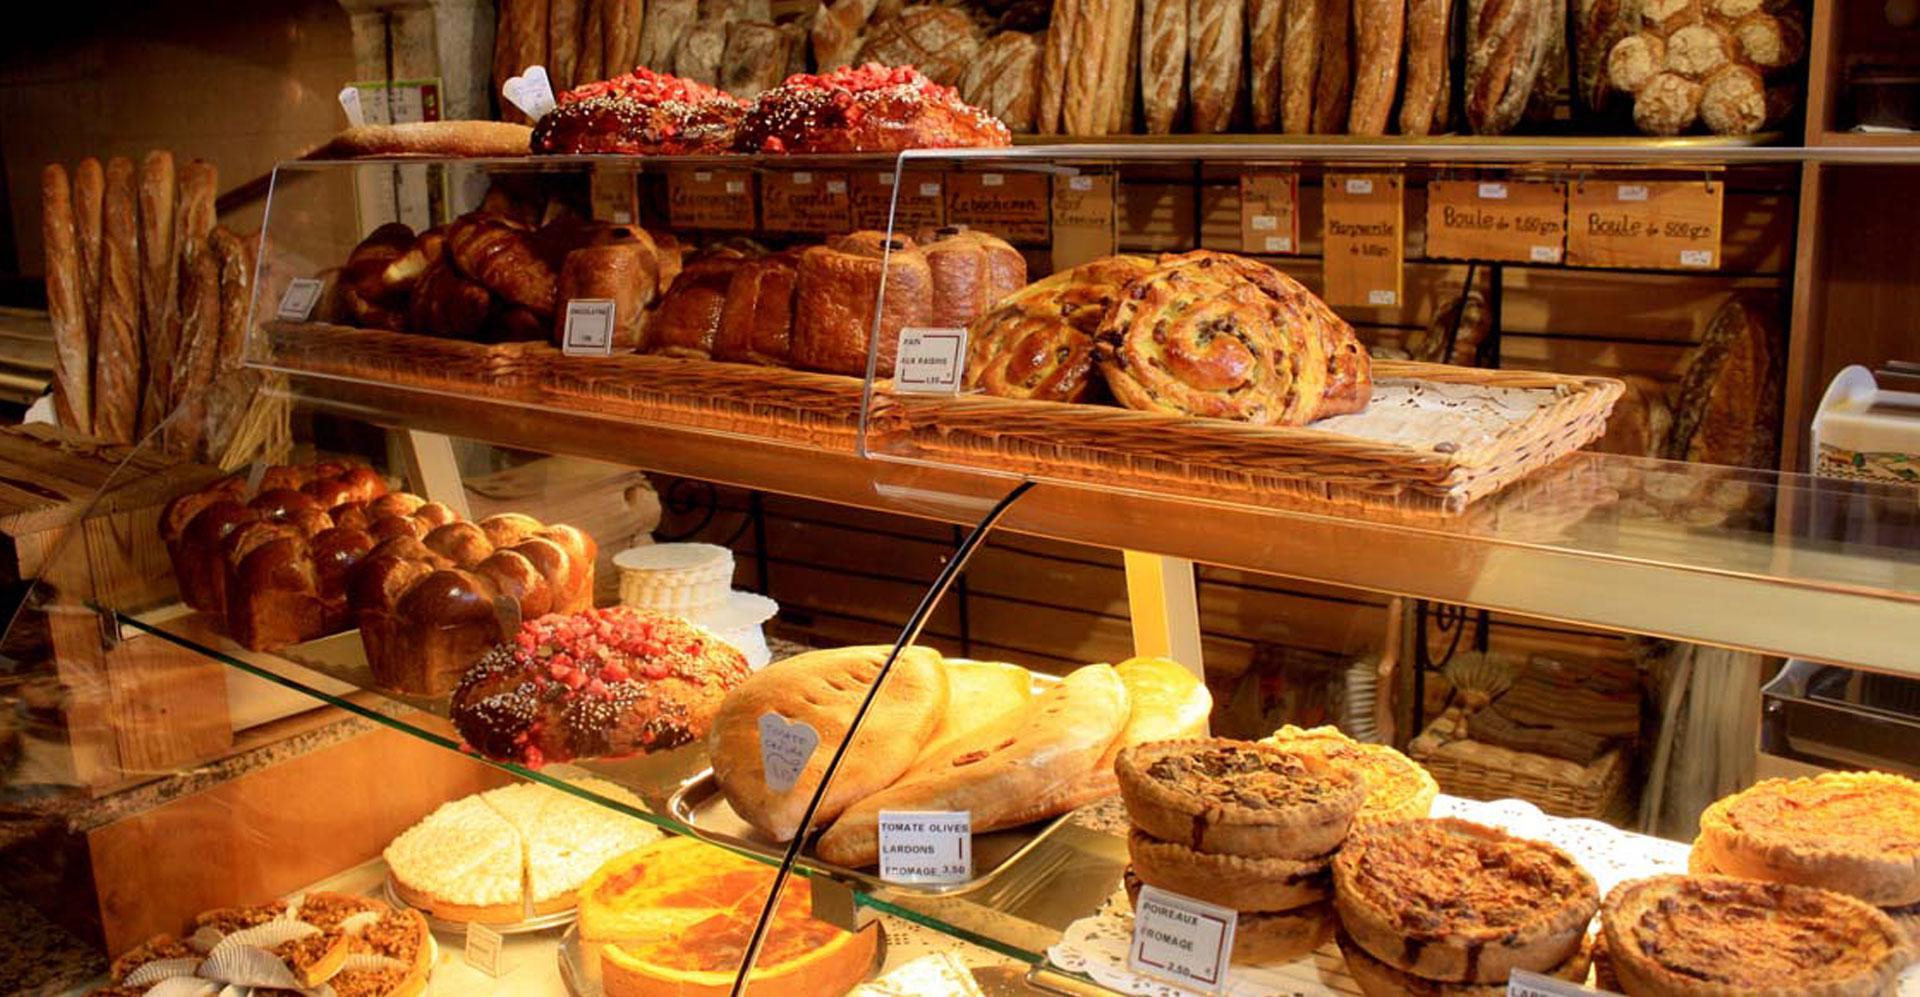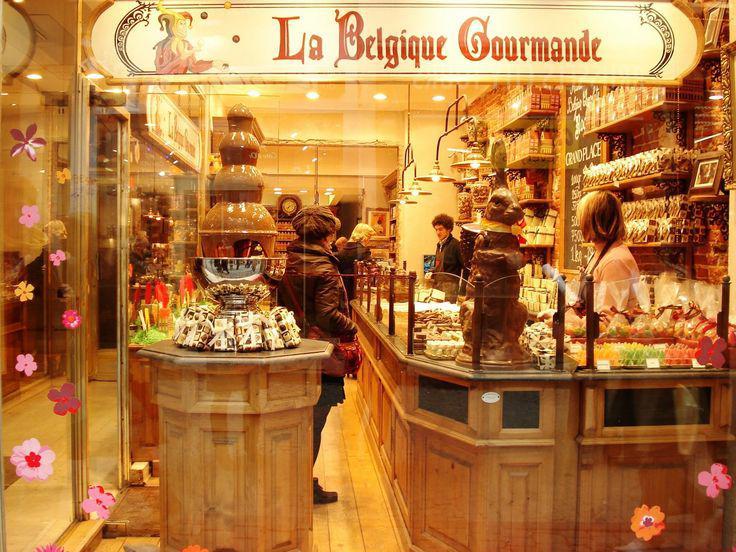The first image is the image on the left, the second image is the image on the right. For the images shown, is this caption "One female worker with a white top and no hat is behind a glass display case that turns a corner, in one image." true? Answer yes or no. No. The first image is the image on the left, the second image is the image on the right. Assess this claim about the two images: "A sign announces the name of the bakery in the image on the right.". Correct or not? Answer yes or no. Yes. 